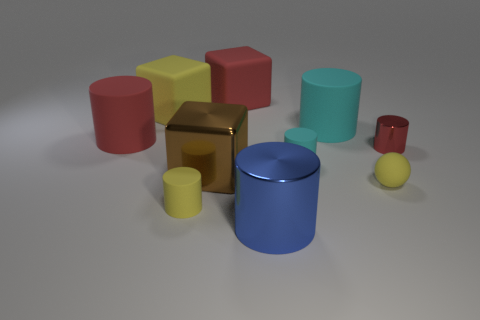There is a red rubber thing to the right of the large red matte cylinder; is it the same shape as the tiny shiny thing? No, the red rubber object to the right of the large red matte cylinder is not the same shape as the tiny shiny object. The red rubber item is cylindrical in shape, whereas the tiny shiny object has a spherical form. 